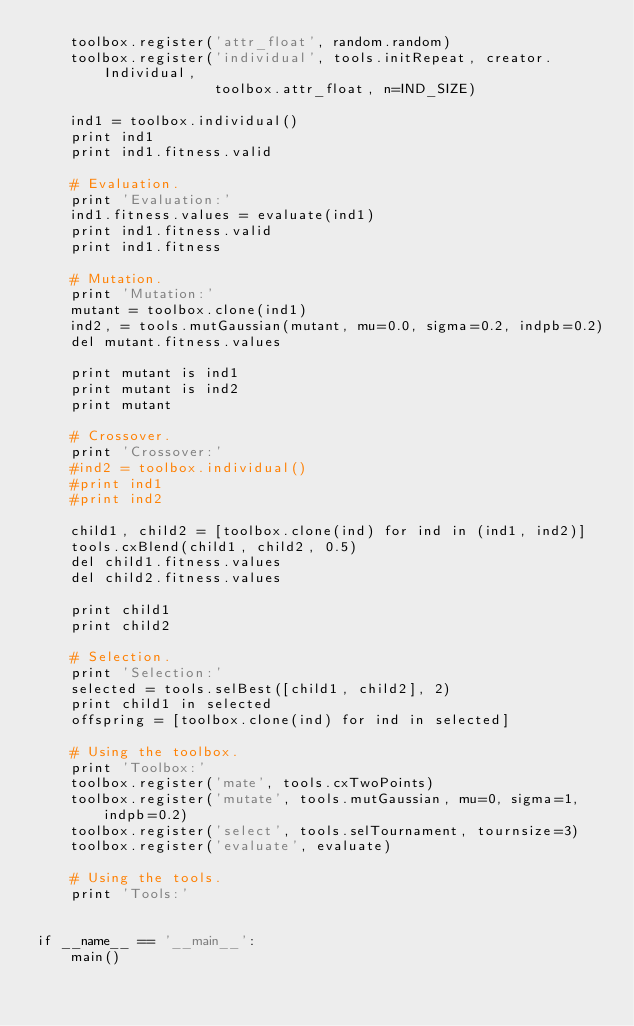Convert code to text. <code><loc_0><loc_0><loc_500><loc_500><_Python_>    toolbox.register('attr_float', random.random)
    toolbox.register('individual', tools.initRepeat, creator.Individual,
                     toolbox.attr_float, n=IND_SIZE)

    ind1 = toolbox.individual()
    print ind1
    print ind1.fitness.valid

    # Evaluation.
    print 'Evaluation:'
    ind1.fitness.values = evaluate(ind1)
    print ind1.fitness.valid
    print ind1.fitness

    # Mutation.
    print 'Mutation:'
    mutant = toolbox.clone(ind1)
    ind2, = tools.mutGaussian(mutant, mu=0.0, sigma=0.2, indpb=0.2)
    del mutant.fitness.values

    print mutant is ind1
    print mutant is ind2
    print mutant

    # Crossover.
    print 'Crossover:'
    #ind2 = toolbox.individual()
    #print ind1
    #print ind2

    child1, child2 = [toolbox.clone(ind) for ind in (ind1, ind2)]
    tools.cxBlend(child1, child2, 0.5)
    del child1.fitness.values
    del child2.fitness.values

    print child1
    print child2

    # Selection.
    print 'Selection:'
    selected = tools.selBest([child1, child2], 2)
    print child1 in selected
    offspring = [toolbox.clone(ind) for ind in selected]

    # Using the toolbox.
    print 'Toolbox:'
    toolbox.register('mate', tools.cxTwoPoints)
    toolbox.register('mutate', tools.mutGaussian, mu=0, sigma=1, indpb=0.2)
    toolbox.register('select', tools.selTournament, tournsize=3)
    toolbox.register('evaluate', evaluate)

    # Using the tools.
    print 'Tools:'


if __name__ == '__main__':
    main()
</code> 